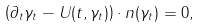Convert formula to latex. <formula><loc_0><loc_0><loc_500><loc_500>\left ( \partial _ { t } \gamma _ { t } - U ( t , \gamma _ { t } ) \right ) \cdot n ( \gamma _ { t } ) = 0 ,</formula> 